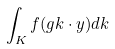Convert formula to latex. <formula><loc_0><loc_0><loc_500><loc_500>\int _ { K } f ( g k \cdot y ) d k</formula> 